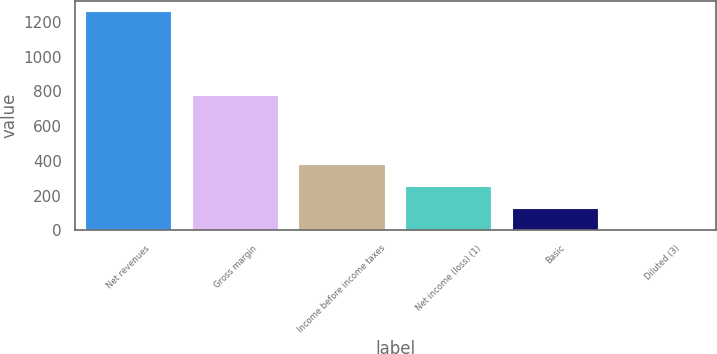<chart> <loc_0><loc_0><loc_500><loc_500><bar_chart><fcel>Net revenues<fcel>Gross margin<fcel>Income before income taxes<fcel>Net income (loss) (1)<fcel>Basic<fcel>Diluted (3)<nl><fcel>1257.8<fcel>772.4<fcel>377.65<fcel>251.91<fcel>126.17<fcel>0.43<nl></chart> 